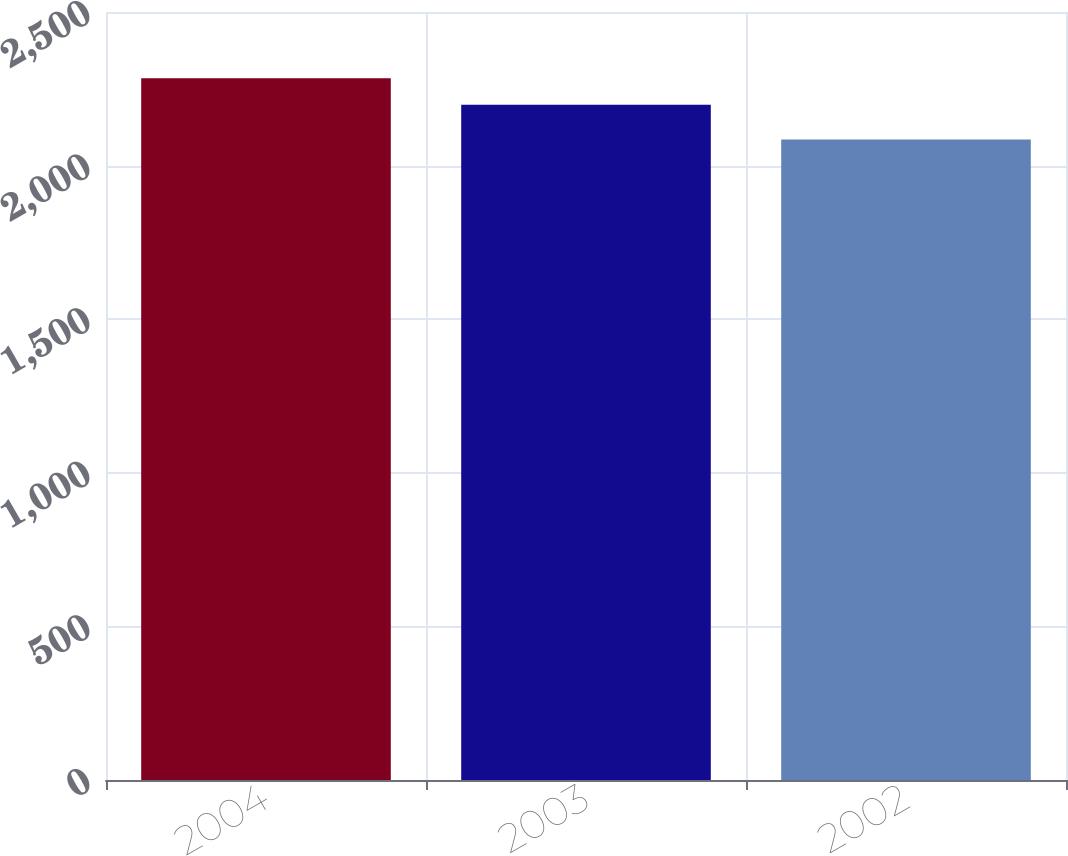Convert chart. <chart><loc_0><loc_0><loc_500><loc_500><bar_chart><fcel>2004<fcel>2003<fcel>2002<nl><fcel>2284<fcel>2198<fcel>2085<nl></chart> 